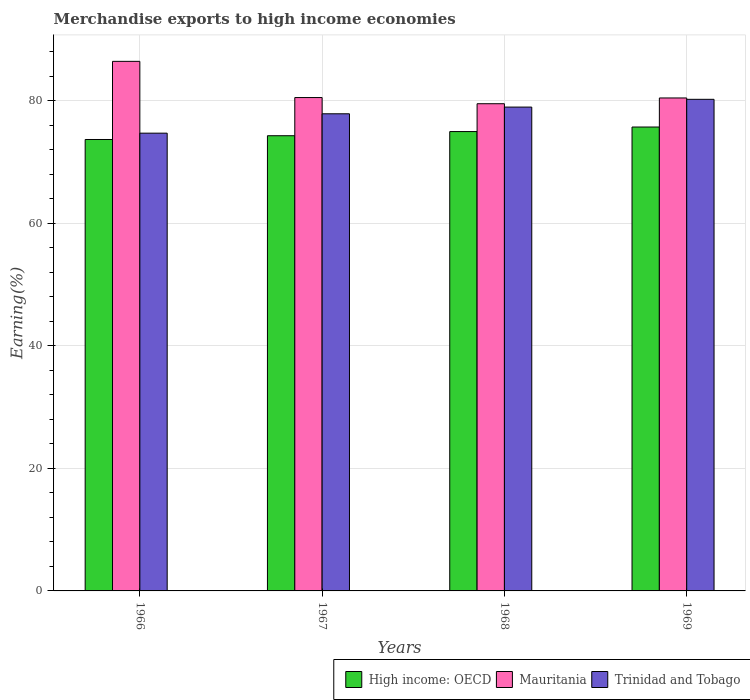How many different coloured bars are there?
Your response must be concise. 3. Are the number of bars on each tick of the X-axis equal?
Offer a very short reply. Yes. How many bars are there on the 1st tick from the left?
Keep it short and to the point. 3. What is the label of the 4th group of bars from the left?
Keep it short and to the point. 1969. In how many cases, is the number of bars for a given year not equal to the number of legend labels?
Provide a short and direct response. 0. What is the percentage of amount earned from merchandise exports in High income: OECD in 1966?
Offer a terse response. 73.65. Across all years, what is the maximum percentage of amount earned from merchandise exports in Mauritania?
Give a very brief answer. 86.4. Across all years, what is the minimum percentage of amount earned from merchandise exports in High income: OECD?
Your answer should be compact. 73.65. In which year was the percentage of amount earned from merchandise exports in High income: OECD maximum?
Provide a short and direct response. 1969. In which year was the percentage of amount earned from merchandise exports in Trinidad and Tobago minimum?
Provide a succinct answer. 1966. What is the total percentage of amount earned from merchandise exports in Trinidad and Tobago in the graph?
Provide a short and direct response. 311.66. What is the difference between the percentage of amount earned from merchandise exports in Trinidad and Tobago in 1967 and that in 1968?
Offer a very short reply. -1.09. What is the difference between the percentage of amount earned from merchandise exports in Mauritania in 1968 and the percentage of amount earned from merchandise exports in High income: OECD in 1969?
Offer a very short reply. 3.8. What is the average percentage of amount earned from merchandise exports in Trinidad and Tobago per year?
Offer a terse response. 77.92. In the year 1968, what is the difference between the percentage of amount earned from merchandise exports in Trinidad and Tobago and percentage of amount earned from merchandise exports in High income: OECD?
Provide a succinct answer. 3.99. What is the ratio of the percentage of amount earned from merchandise exports in High income: OECD in 1966 to that in 1968?
Provide a short and direct response. 0.98. Is the percentage of amount earned from merchandise exports in High income: OECD in 1966 less than that in 1967?
Your answer should be very brief. Yes. What is the difference between the highest and the second highest percentage of amount earned from merchandise exports in Mauritania?
Provide a short and direct response. 5.91. What is the difference between the highest and the lowest percentage of amount earned from merchandise exports in Mauritania?
Make the answer very short. 6.91. In how many years, is the percentage of amount earned from merchandise exports in Trinidad and Tobago greater than the average percentage of amount earned from merchandise exports in Trinidad and Tobago taken over all years?
Keep it short and to the point. 2. Is the sum of the percentage of amount earned from merchandise exports in Trinidad and Tobago in 1967 and 1968 greater than the maximum percentage of amount earned from merchandise exports in Mauritania across all years?
Your answer should be very brief. Yes. What does the 2nd bar from the left in 1966 represents?
Ensure brevity in your answer.  Mauritania. What does the 1st bar from the right in 1967 represents?
Your response must be concise. Trinidad and Tobago. Is it the case that in every year, the sum of the percentage of amount earned from merchandise exports in Trinidad and Tobago and percentage of amount earned from merchandise exports in High income: OECD is greater than the percentage of amount earned from merchandise exports in Mauritania?
Your answer should be very brief. Yes. Are all the bars in the graph horizontal?
Your answer should be compact. No. Does the graph contain any zero values?
Your answer should be very brief. No. Does the graph contain grids?
Your response must be concise. Yes. Where does the legend appear in the graph?
Your answer should be very brief. Bottom right. What is the title of the graph?
Provide a short and direct response. Merchandise exports to high income economies. Does "Hungary" appear as one of the legend labels in the graph?
Ensure brevity in your answer.  No. What is the label or title of the Y-axis?
Offer a terse response. Earning(%). What is the Earning(%) of High income: OECD in 1966?
Offer a very short reply. 73.65. What is the Earning(%) in Mauritania in 1966?
Keep it short and to the point. 86.4. What is the Earning(%) in Trinidad and Tobago in 1966?
Ensure brevity in your answer.  74.68. What is the Earning(%) in High income: OECD in 1967?
Your answer should be compact. 74.26. What is the Earning(%) in Mauritania in 1967?
Keep it short and to the point. 80.49. What is the Earning(%) of Trinidad and Tobago in 1967?
Keep it short and to the point. 77.84. What is the Earning(%) of High income: OECD in 1968?
Keep it short and to the point. 74.94. What is the Earning(%) of Mauritania in 1968?
Your answer should be very brief. 79.48. What is the Earning(%) in Trinidad and Tobago in 1968?
Your answer should be compact. 78.93. What is the Earning(%) in High income: OECD in 1969?
Offer a terse response. 75.68. What is the Earning(%) of Mauritania in 1969?
Make the answer very short. 80.42. What is the Earning(%) in Trinidad and Tobago in 1969?
Offer a terse response. 80.2. Across all years, what is the maximum Earning(%) in High income: OECD?
Make the answer very short. 75.68. Across all years, what is the maximum Earning(%) of Mauritania?
Ensure brevity in your answer.  86.4. Across all years, what is the maximum Earning(%) in Trinidad and Tobago?
Your answer should be compact. 80.2. Across all years, what is the minimum Earning(%) in High income: OECD?
Provide a short and direct response. 73.65. Across all years, what is the minimum Earning(%) of Mauritania?
Provide a short and direct response. 79.48. Across all years, what is the minimum Earning(%) of Trinidad and Tobago?
Offer a terse response. 74.68. What is the total Earning(%) of High income: OECD in the graph?
Offer a terse response. 298.53. What is the total Earning(%) of Mauritania in the graph?
Keep it short and to the point. 326.79. What is the total Earning(%) of Trinidad and Tobago in the graph?
Your answer should be compact. 311.66. What is the difference between the Earning(%) of High income: OECD in 1966 and that in 1967?
Ensure brevity in your answer.  -0.62. What is the difference between the Earning(%) of Mauritania in 1966 and that in 1967?
Offer a terse response. 5.91. What is the difference between the Earning(%) in Trinidad and Tobago in 1966 and that in 1967?
Your answer should be very brief. -3.16. What is the difference between the Earning(%) in High income: OECD in 1966 and that in 1968?
Your response must be concise. -1.29. What is the difference between the Earning(%) of Mauritania in 1966 and that in 1968?
Offer a very short reply. 6.91. What is the difference between the Earning(%) in Trinidad and Tobago in 1966 and that in 1968?
Make the answer very short. -4.25. What is the difference between the Earning(%) of High income: OECD in 1966 and that in 1969?
Ensure brevity in your answer.  -2.04. What is the difference between the Earning(%) of Mauritania in 1966 and that in 1969?
Keep it short and to the point. 5.97. What is the difference between the Earning(%) of Trinidad and Tobago in 1966 and that in 1969?
Offer a terse response. -5.52. What is the difference between the Earning(%) of High income: OECD in 1967 and that in 1968?
Make the answer very short. -0.68. What is the difference between the Earning(%) in Mauritania in 1967 and that in 1968?
Provide a succinct answer. 1.01. What is the difference between the Earning(%) in Trinidad and Tobago in 1967 and that in 1968?
Keep it short and to the point. -1.09. What is the difference between the Earning(%) of High income: OECD in 1967 and that in 1969?
Offer a terse response. -1.42. What is the difference between the Earning(%) in Mauritania in 1967 and that in 1969?
Your answer should be compact. 0.07. What is the difference between the Earning(%) in Trinidad and Tobago in 1967 and that in 1969?
Offer a terse response. -2.36. What is the difference between the Earning(%) of High income: OECD in 1968 and that in 1969?
Ensure brevity in your answer.  -0.74. What is the difference between the Earning(%) of Mauritania in 1968 and that in 1969?
Your answer should be very brief. -0.94. What is the difference between the Earning(%) in Trinidad and Tobago in 1968 and that in 1969?
Offer a very short reply. -1.27. What is the difference between the Earning(%) in High income: OECD in 1966 and the Earning(%) in Mauritania in 1967?
Keep it short and to the point. -6.84. What is the difference between the Earning(%) in High income: OECD in 1966 and the Earning(%) in Trinidad and Tobago in 1967?
Give a very brief answer. -4.19. What is the difference between the Earning(%) in Mauritania in 1966 and the Earning(%) in Trinidad and Tobago in 1967?
Your response must be concise. 8.55. What is the difference between the Earning(%) of High income: OECD in 1966 and the Earning(%) of Mauritania in 1968?
Your response must be concise. -5.84. What is the difference between the Earning(%) in High income: OECD in 1966 and the Earning(%) in Trinidad and Tobago in 1968?
Make the answer very short. -5.29. What is the difference between the Earning(%) of Mauritania in 1966 and the Earning(%) of Trinidad and Tobago in 1968?
Your response must be concise. 7.46. What is the difference between the Earning(%) of High income: OECD in 1966 and the Earning(%) of Mauritania in 1969?
Provide a succinct answer. -6.78. What is the difference between the Earning(%) in High income: OECD in 1966 and the Earning(%) in Trinidad and Tobago in 1969?
Provide a short and direct response. -6.56. What is the difference between the Earning(%) in Mauritania in 1966 and the Earning(%) in Trinidad and Tobago in 1969?
Your answer should be very brief. 6.19. What is the difference between the Earning(%) of High income: OECD in 1967 and the Earning(%) of Mauritania in 1968?
Your response must be concise. -5.22. What is the difference between the Earning(%) of High income: OECD in 1967 and the Earning(%) of Trinidad and Tobago in 1968?
Make the answer very short. -4.67. What is the difference between the Earning(%) in Mauritania in 1967 and the Earning(%) in Trinidad and Tobago in 1968?
Provide a short and direct response. 1.56. What is the difference between the Earning(%) in High income: OECD in 1967 and the Earning(%) in Mauritania in 1969?
Provide a short and direct response. -6.16. What is the difference between the Earning(%) of High income: OECD in 1967 and the Earning(%) of Trinidad and Tobago in 1969?
Offer a very short reply. -5.94. What is the difference between the Earning(%) in Mauritania in 1967 and the Earning(%) in Trinidad and Tobago in 1969?
Your answer should be compact. 0.29. What is the difference between the Earning(%) of High income: OECD in 1968 and the Earning(%) of Mauritania in 1969?
Provide a succinct answer. -5.48. What is the difference between the Earning(%) in High income: OECD in 1968 and the Earning(%) in Trinidad and Tobago in 1969?
Provide a short and direct response. -5.26. What is the difference between the Earning(%) in Mauritania in 1968 and the Earning(%) in Trinidad and Tobago in 1969?
Your answer should be very brief. -0.72. What is the average Earning(%) in High income: OECD per year?
Provide a succinct answer. 74.63. What is the average Earning(%) of Mauritania per year?
Ensure brevity in your answer.  81.7. What is the average Earning(%) of Trinidad and Tobago per year?
Your answer should be very brief. 77.92. In the year 1966, what is the difference between the Earning(%) in High income: OECD and Earning(%) in Mauritania?
Offer a terse response. -12.75. In the year 1966, what is the difference between the Earning(%) in High income: OECD and Earning(%) in Trinidad and Tobago?
Your response must be concise. -1.03. In the year 1966, what is the difference between the Earning(%) of Mauritania and Earning(%) of Trinidad and Tobago?
Offer a very short reply. 11.72. In the year 1967, what is the difference between the Earning(%) in High income: OECD and Earning(%) in Mauritania?
Your response must be concise. -6.23. In the year 1967, what is the difference between the Earning(%) in High income: OECD and Earning(%) in Trinidad and Tobago?
Your response must be concise. -3.58. In the year 1967, what is the difference between the Earning(%) in Mauritania and Earning(%) in Trinidad and Tobago?
Give a very brief answer. 2.65. In the year 1968, what is the difference between the Earning(%) in High income: OECD and Earning(%) in Mauritania?
Provide a short and direct response. -4.54. In the year 1968, what is the difference between the Earning(%) of High income: OECD and Earning(%) of Trinidad and Tobago?
Offer a very short reply. -3.99. In the year 1968, what is the difference between the Earning(%) in Mauritania and Earning(%) in Trinidad and Tobago?
Keep it short and to the point. 0.55. In the year 1969, what is the difference between the Earning(%) in High income: OECD and Earning(%) in Mauritania?
Keep it short and to the point. -4.74. In the year 1969, what is the difference between the Earning(%) in High income: OECD and Earning(%) in Trinidad and Tobago?
Offer a very short reply. -4.52. In the year 1969, what is the difference between the Earning(%) of Mauritania and Earning(%) of Trinidad and Tobago?
Your response must be concise. 0.22. What is the ratio of the Earning(%) of Mauritania in 1966 to that in 1967?
Your answer should be very brief. 1.07. What is the ratio of the Earning(%) in Trinidad and Tobago in 1966 to that in 1967?
Your answer should be very brief. 0.96. What is the ratio of the Earning(%) in High income: OECD in 1966 to that in 1968?
Your answer should be very brief. 0.98. What is the ratio of the Earning(%) of Mauritania in 1966 to that in 1968?
Your answer should be compact. 1.09. What is the ratio of the Earning(%) in Trinidad and Tobago in 1966 to that in 1968?
Make the answer very short. 0.95. What is the ratio of the Earning(%) of High income: OECD in 1966 to that in 1969?
Offer a terse response. 0.97. What is the ratio of the Earning(%) of Mauritania in 1966 to that in 1969?
Keep it short and to the point. 1.07. What is the ratio of the Earning(%) in Trinidad and Tobago in 1966 to that in 1969?
Your response must be concise. 0.93. What is the ratio of the Earning(%) of High income: OECD in 1967 to that in 1968?
Provide a succinct answer. 0.99. What is the ratio of the Earning(%) in Mauritania in 1967 to that in 1968?
Offer a very short reply. 1.01. What is the ratio of the Earning(%) of Trinidad and Tobago in 1967 to that in 1968?
Make the answer very short. 0.99. What is the ratio of the Earning(%) in High income: OECD in 1967 to that in 1969?
Provide a short and direct response. 0.98. What is the ratio of the Earning(%) of Trinidad and Tobago in 1967 to that in 1969?
Give a very brief answer. 0.97. What is the ratio of the Earning(%) of High income: OECD in 1968 to that in 1969?
Make the answer very short. 0.99. What is the ratio of the Earning(%) of Mauritania in 1968 to that in 1969?
Provide a succinct answer. 0.99. What is the ratio of the Earning(%) of Trinidad and Tobago in 1968 to that in 1969?
Your answer should be very brief. 0.98. What is the difference between the highest and the second highest Earning(%) in High income: OECD?
Offer a very short reply. 0.74. What is the difference between the highest and the second highest Earning(%) of Mauritania?
Make the answer very short. 5.91. What is the difference between the highest and the second highest Earning(%) of Trinidad and Tobago?
Offer a terse response. 1.27. What is the difference between the highest and the lowest Earning(%) of High income: OECD?
Make the answer very short. 2.04. What is the difference between the highest and the lowest Earning(%) of Mauritania?
Offer a terse response. 6.91. What is the difference between the highest and the lowest Earning(%) of Trinidad and Tobago?
Your response must be concise. 5.52. 